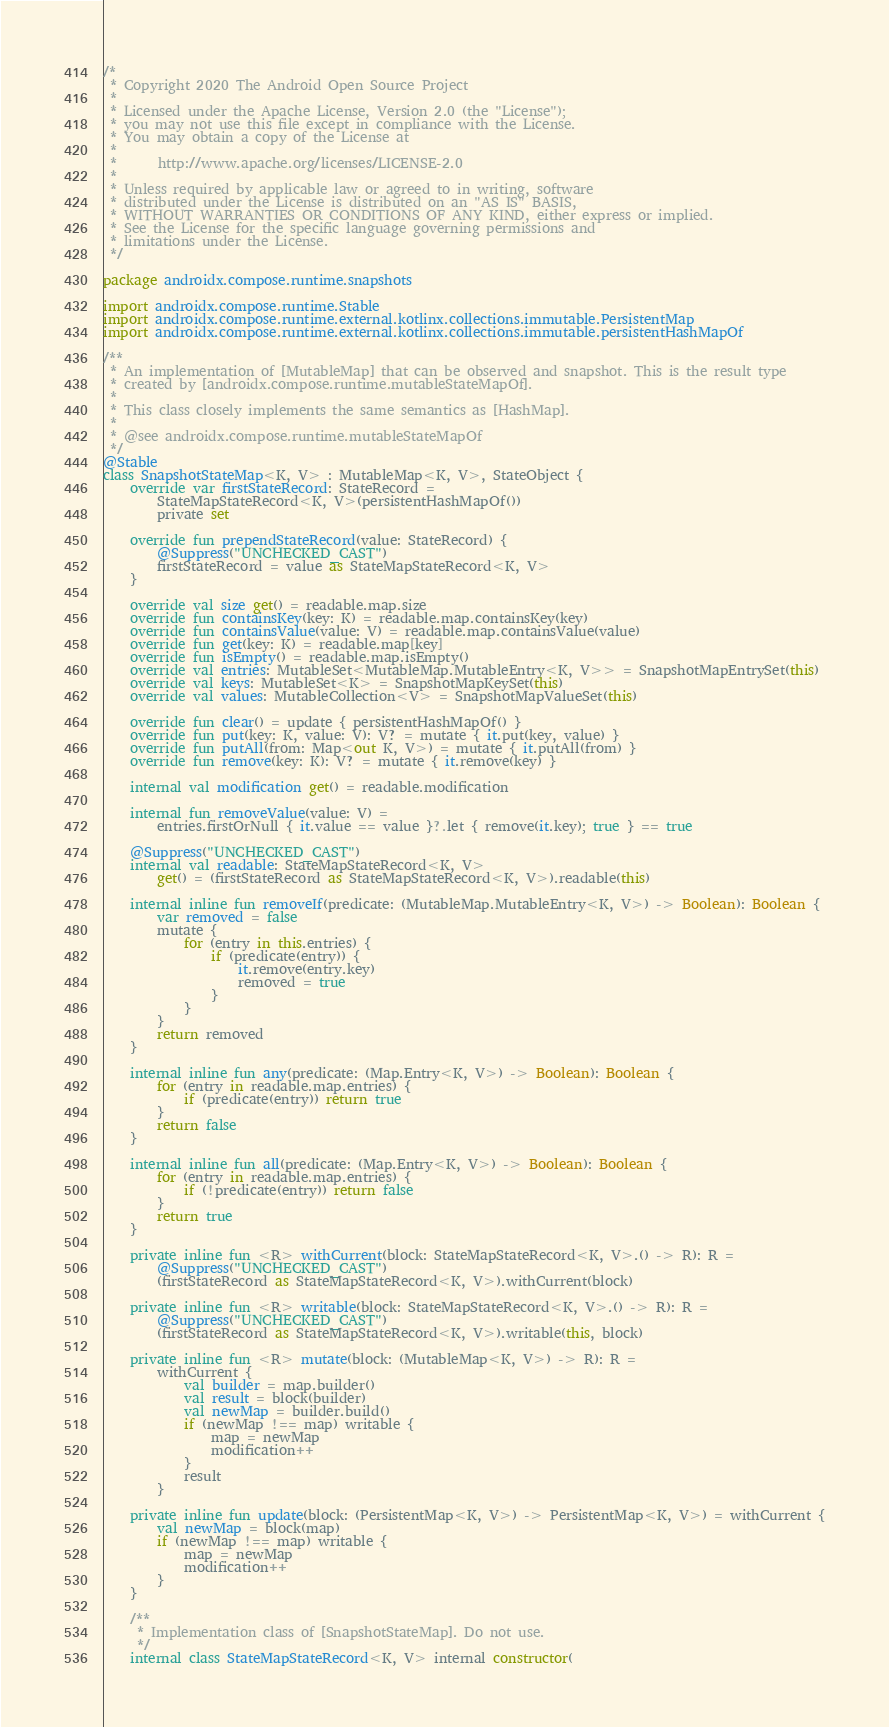Convert code to text. <code><loc_0><loc_0><loc_500><loc_500><_Kotlin_>/*
 * Copyright 2020 The Android Open Source Project
 *
 * Licensed under the Apache License, Version 2.0 (the "License");
 * you may not use this file except in compliance with the License.
 * You may obtain a copy of the License at
 *
 *      http://www.apache.org/licenses/LICENSE-2.0
 *
 * Unless required by applicable law or agreed to in writing, software
 * distributed under the License is distributed on an "AS IS" BASIS,
 * WITHOUT WARRANTIES OR CONDITIONS OF ANY KIND, either express or implied.
 * See the License for the specific language governing permissions and
 * limitations under the License.
 */

package androidx.compose.runtime.snapshots

import androidx.compose.runtime.Stable
import androidx.compose.runtime.external.kotlinx.collections.immutable.PersistentMap
import androidx.compose.runtime.external.kotlinx.collections.immutable.persistentHashMapOf

/**
 * An implementation of [MutableMap] that can be observed and snapshot. This is the result type
 * created by [androidx.compose.runtime.mutableStateMapOf].
 *
 * This class closely implements the same semantics as [HashMap].
 *
 * @see androidx.compose.runtime.mutableStateMapOf
 */
@Stable
class SnapshotStateMap<K, V> : MutableMap<K, V>, StateObject {
    override var firstStateRecord: StateRecord =
        StateMapStateRecord<K, V>(persistentHashMapOf())
        private set

    override fun prependStateRecord(value: StateRecord) {
        @Suppress("UNCHECKED_CAST")
        firstStateRecord = value as StateMapStateRecord<K, V>
    }

    override val size get() = readable.map.size
    override fun containsKey(key: K) = readable.map.containsKey(key)
    override fun containsValue(value: V) = readable.map.containsValue(value)
    override fun get(key: K) = readable.map[key]
    override fun isEmpty() = readable.map.isEmpty()
    override val entries: MutableSet<MutableMap.MutableEntry<K, V>> = SnapshotMapEntrySet(this)
    override val keys: MutableSet<K> = SnapshotMapKeySet(this)
    override val values: MutableCollection<V> = SnapshotMapValueSet(this)

    override fun clear() = update { persistentHashMapOf() }
    override fun put(key: K, value: V): V? = mutate { it.put(key, value) }
    override fun putAll(from: Map<out K, V>) = mutate { it.putAll(from) }
    override fun remove(key: K): V? = mutate { it.remove(key) }

    internal val modification get() = readable.modification

    internal fun removeValue(value: V) =
        entries.firstOrNull { it.value == value }?.let { remove(it.key); true } == true

    @Suppress("UNCHECKED_CAST")
    internal val readable: StateMapStateRecord<K, V>
        get() = (firstStateRecord as StateMapStateRecord<K, V>).readable(this)

    internal inline fun removeIf(predicate: (MutableMap.MutableEntry<K, V>) -> Boolean): Boolean {
        var removed = false
        mutate {
            for (entry in this.entries) {
                if (predicate(entry)) {
                    it.remove(entry.key)
                    removed = true
                }
            }
        }
        return removed
    }

    internal inline fun any(predicate: (Map.Entry<K, V>) -> Boolean): Boolean {
        for (entry in readable.map.entries) {
            if (predicate(entry)) return true
        }
        return false
    }

    internal inline fun all(predicate: (Map.Entry<K, V>) -> Boolean): Boolean {
        for (entry in readable.map.entries) {
            if (!predicate(entry)) return false
        }
        return true
    }

    private inline fun <R> withCurrent(block: StateMapStateRecord<K, V>.() -> R): R =
        @Suppress("UNCHECKED_CAST")
        (firstStateRecord as StateMapStateRecord<K, V>).withCurrent(block)

    private inline fun <R> writable(block: StateMapStateRecord<K, V>.() -> R): R =
        @Suppress("UNCHECKED_CAST")
        (firstStateRecord as StateMapStateRecord<K, V>).writable(this, block)

    private inline fun <R> mutate(block: (MutableMap<K, V>) -> R): R =
        withCurrent {
            val builder = map.builder()
            val result = block(builder)
            val newMap = builder.build()
            if (newMap !== map) writable {
                map = newMap
                modification++
            }
            result
        }

    private inline fun update(block: (PersistentMap<K, V>) -> PersistentMap<K, V>) = withCurrent {
        val newMap = block(map)
        if (newMap !== map) writable {
            map = newMap
            modification++
        }
    }

    /**
     * Implementation class of [SnapshotStateMap]. Do not use.
     */
    internal class StateMapStateRecord<K, V> internal constructor(</code> 